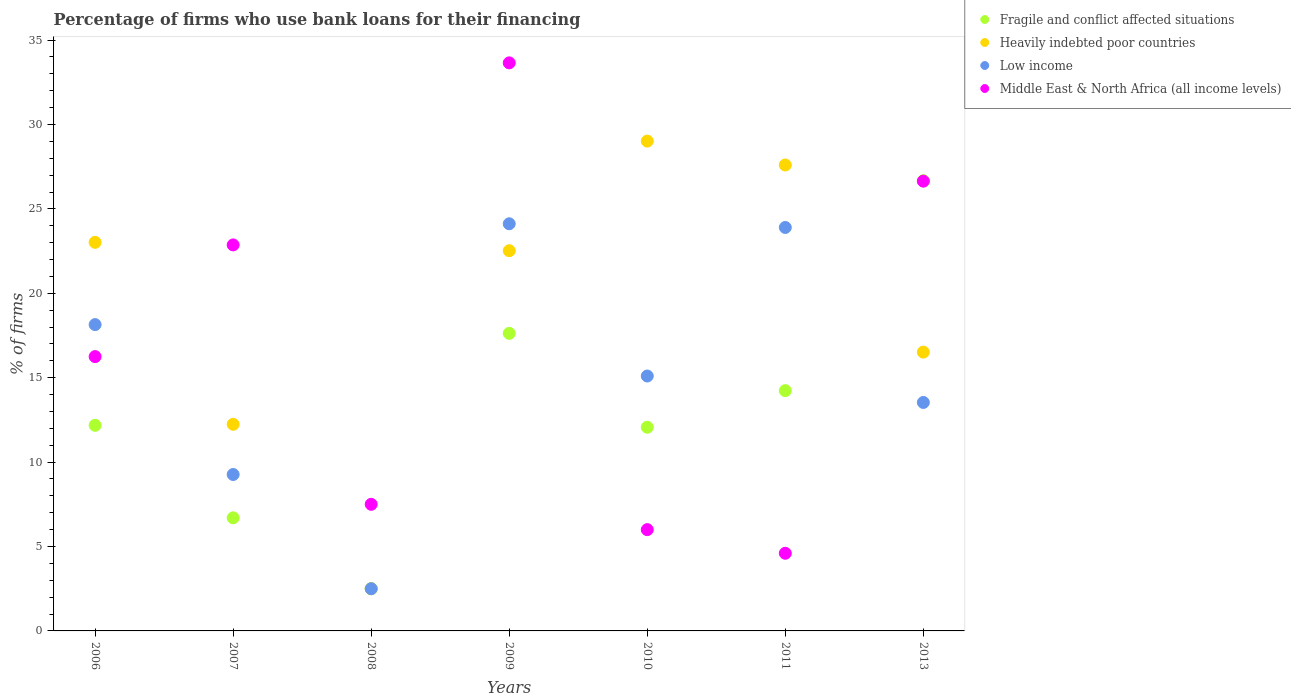How many different coloured dotlines are there?
Keep it short and to the point. 4. What is the percentage of firms who use bank loans for their financing in Low income in 2009?
Give a very brief answer. 24.12. Across all years, what is the maximum percentage of firms who use bank loans for their financing in Low income?
Offer a very short reply. 24.12. Across all years, what is the minimum percentage of firms who use bank loans for their financing in Middle East & North Africa (all income levels)?
Make the answer very short. 4.6. In which year was the percentage of firms who use bank loans for their financing in Middle East & North Africa (all income levels) minimum?
Offer a very short reply. 2011. What is the total percentage of firms who use bank loans for their financing in Fragile and conflict affected situations in the graph?
Offer a very short reply. 91.98. What is the difference between the percentage of firms who use bank loans for their financing in Low income in 2006 and that in 2013?
Your answer should be compact. 4.61. What is the difference between the percentage of firms who use bank loans for their financing in Middle East & North Africa (all income levels) in 2009 and the percentage of firms who use bank loans for their financing in Heavily indebted poor countries in 2007?
Provide a succinct answer. 21.41. What is the average percentage of firms who use bank loans for their financing in Fragile and conflict affected situations per year?
Provide a succinct answer. 13.14. What is the ratio of the percentage of firms who use bank loans for their financing in Fragile and conflict affected situations in 2011 to that in 2013?
Ensure brevity in your answer.  0.53. What is the difference between the highest and the second highest percentage of firms who use bank loans for their financing in Low income?
Offer a terse response. 0.22. What is the difference between the highest and the lowest percentage of firms who use bank loans for their financing in Fragile and conflict affected situations?
Your answer should be compact. 24.17. In how many years, is the percentage of firms who use bank loans for their financing in Heavily indebted poor countries greater than the average percentage of firms who use bank loans for their financing in Heavily indebted poor countries taken over all years?
Keep it short and to the point. 4. Is the sum of the percentage of firms who use bank loans for their financing in Low income in 2006 and 2010 greater than the maximum percentage of firms who use bank loans for their financing in Heavily indebted poor countries across all years?
Your answer should be compact. Yes. Is it the case that in every year, the sum of the percentage of firms who use bank loans for their financing in Middle East & North Africa (all income levels) and percentage of firms who use bank loans for their financing in Fragile and conflict affected situations  is greater than the percentage of firms who use bank loans for their financing in Heavily indebted poor countries?
Your answer should be compact. No. Does the percentage of firms who use bank loans for their financing in Heavily indebted poor countries monotonically increase over the years?
Provide a short and direct response. No. Is the percentage of firms who use bank loans for their financing in Heavily indebted poor countries strictly less than the percentage of firms who use bank loans for their financing in Middle East & North Africa (all income levels) over the years?
Offer a very short reply. No. How many dotlines are there?
Your answer should be very brief. 4. Are the values on the major ticks of Y-axis written in scientific E-notation?
Your response must be concise. No. Does the graph contain any zero values?
Ensure brevity in your answer.  No. Does the graph contain grids?
Provide a short and direct response. No. Where does the legend appear in the graph?
Your answer should be very brief. Top right. How are the legend labels stacked?
Keep it short and to the point. Vertical. What is the title of the graph?
Offer a very short reply. Percentage of firms who use bank loans for their financing. What is the label or title of the Y-axis?
Your response must be concise. % of firms. What is the % of firms in Fragile and conflict affected situations in 2006?
Make the answer very short. 12.18. What is the % of firms of Heavily indebted poor countries in 2006?
Offer a terse response. 23.02. What is the % of firms of Low income in 2006?
Offer a terse response. 18.15. What is the % of firms in Middle East & North Africa (all income levels) in 2006?
Give a very brief answer. 16.25. What is the % of firms of Fragile and conflict affected situations in 2007?
Keep it short and to the point. 6.7. What is the % of firms of Heavily indebted poor countries in 2007?
Ensure brevity in your answer.  12.24. What is the % of firms of Low income in 2007?
Keep it short and to the point. 9.27. What is the % of firms of Middle East & North Africa (all income levels) in 2007?
Your answer should be compact. 22.87. What is the % of firms in Low income in 2008?
Provide a short and direct response. 2.5. What is the % of firms of Middle East & North Africa (all income levels) in 2008?
Make the answer very short. 7.5. What is the % of firms of Fragile and conflict affected situations in 2009?
Provide a short and direct response. 17.63. What is the % of firms in Heavily indebted poor countries in 2009?
Provide a short and direct response. 22.52. What is the % of firms of Low income in 2009?
Your answer should be very brief. 24.12. What is the % of firms of Middle East & North Africa (all income levels) in 2009?
Keep it short and to the point. 33.65. What is the % of firms of Fragile and conflict affected situations in 2010?
Provide a short and direct response. 12.07. What is the % of firms of Heavily indebted poor countries in 2010?
Offer a very short reply. 29.02. What is the % of firms in Fragile and conflict affected situations in 2011?
Make the answer very short. 14.23. What is the % of firms of Heavily indebted poor countries in 2011?
Offer a very short reply. 27.6. What is the % of firms in Low income in 2011?
Provide a short and direct response. 23.9. What is the % of firms in Fragile and conflict affected situations in 2013?
Provide a succinct answer. 26.67. What is the % of firms in Heavily indebted poor countries in 2013?
Your answer should be very brief. 16.52. What is the % of firms of Low income in 2013?
Your answer should be compact. 13.53. What is the % of firms of Middle East & North Africa (all income levels) in 2013?
Make the answer very short. 26.64. Across all years, what is the maximum % of firms of Fragile and conflict affected situations?
Provide a short and direct response. 26.67. Across all years, what is the maximum % of firms in Heavily indebted poor countries?
Provide a short and direct response. 29.02. Across all years, what is the maximum % of firms of Low income?
Give a very brief answer. 24.12. Across all years, what is the maximum % of firms in Middle East & North Africa (all income levels)?
Make the answer very short. 33.65. Across all years, what is the minimum % of firms of Heavily indebted poor countries?
Provide a succinct answer. 2.5. What is the total % of firms of Fragile and conflict affected situations in the graph?
Offer a very short reply. 91.98. What is the total % of firms of Heavily indebted poor countries in the graph?
Offer a terse response. 133.42. What is the total % of firms in Low income in the graph?
Offer a terse response. 106.56. What is the total % of firms in Middle East & North Africa (all income levels) in the graph?
Make the answer very short. 117.51. What is the difference between the % of firms of Fragile and conflict affected situations in 2006 and that in 2007?
Offer a terse response. 5.48. What is the difference between the % of firms in Heavily indebted poor countries in 2006 and that in 2007?
Make the answer very short. 10.78. What is the difference between the % of firms in Low income in 2006 and that in 2007?
Your answer should be compact. 8.88. What is the difference between the % of firms in Middle East & North Africa (all income levels) in 2006 and that in 2007?
Ensure brevity in your answer.  -6.62. What is the difference between the % of firms in Fragile and conflict affected situations in 2006 and that in 2008?
Keep it short and to the point. 9.68. What is the difference between the % of firms in Heavily indebted poor countries in 2006 and that in 2008?
Offer a very short reply. 20.52. What is the difference between the % of firms in Low income in 2006 and that in 2008?
Your response must be concise. 15.65. What is the difference between the % of firms of Middle East & North Africa (all income levels) in 2006 and that in 2008?
Offer a very short reply. 8.75. What is the difference between the % of firms of Fragile and conflict affected situations in 2006 and that in 2009?
Ensure brevity in your answer.  -5.45. What is the difference between the % of firms in Heavily indebted poor countries in 2006 and that in 2009?
Keep it short and to the point. 0.5. What is the difference between the % of firms in Low income in 2006 and that in 2009?
Provide a succinct answer. -5.97. What is the difference between the % of firms in Middle East & North Africa (all income levels) in 2006 and that in 2009?
Offer a very short reply. -17.4. What is the difference between the % of firms of Fragile and conflict affected situations in 2006 and that in 2010?
Offer a very short reply. 0.11. What is the difference between the % of firms in Heavily indebted poor countries in 2006 and that in 2010?
Make the answer very short. -6. What is the difference between the % of firms of Low income in 2006 and that in 2010?
Your response must be concise. 3.05. What is the difference between the % of firms of Middle East & North Africa (all income levels) in 2006 and that in 2010?
Offer a very short reply. 10.25. What is the difference between the % of firms in Fragile and conflict affected situations in 2006 and that in 2011?
Ensure brevity in your answer.  -2.05. What is the difference between the % of firms in Heavily indebted poor countries in 2006 and that in 2011?
Provide a succinct answer. -4.58. What is the difference between the % of firms of Low income in 2006 and that in 2011?
Offer a very short reply. -5.75. What is the difference between the % of firms of Middle East & North Africa (all income levels) in 2006 and that in 2011?
Make the answer very short. 11.65. What is the difference between the % of firms in Fragile and conflict affected situations in 2006 and that in 2013?
Provide a succinct answer. -14.49. What is the difference between the % of firms of Heavily indebted poor countries in 2006 and that in 2013?
Your answer should be compact. 6.5. What is the difference between the % of firms in Low income in 2006 and that in 2013?
Your answer should be very brief. 4.61. What is the difference between the % of firms in Middle East & North Africa (all income levels) in 2006 and that in 2013?
Offer a terse response. -10.39. What is the difference between the % of firms in Fragile and conflict affected situations in 2007 and that in 2008?
Provide a succinct answer. 4.2. What is the difference between the % of firms in Heavily indebted poor countries in 2007 and that in 2008?
Offer a terse response. 9.74. What is the difference between the % of firms of Low income in 2007 and that in 2008?
Your answer should be very brief. 6.77. What is the difference between the % of firms of Middle East & North Africa (all income levels) in 2007 and that in 2008?
Provide a succinct answer. 15.37. What is the difference between the % of firms of Fragile and conflict affected situations in 2007 and that in 2009?
Offer a very short reply. -10.93. What is the difference between the % of firms in Heavily indebted poor countries in 2007 and that in 2009?
Your response must be concise. -10.28. What is the difference between the % of firms of Low income in 2007 and that in 2009?
Make the answer very short. -14.85. What is the difference between the % of firms of Middle East & North Africa (all income levels) in 2007 and that in 2009?
Offer a terse response. -10.78. What is the difference between the % of firms of Fragile and conflict affected situations in 2007 and that in 2010?
Your response must be concise. -5.37. What is the difference between the % of firms of Heavily indebted poor countries in 2007 and that in 2010?
Provide a succinct answer. -16.78. What is the difference between the % of firms of Low income in 2007 and that in 2010?
Offer a terse response. -5.83. What is the difference between the % of firms of Middle East & North Africa (all income levels) in 2007 and that in 2010?
Make the answer very short. 16.87. What is the difference between the % of firms of Fragile and conflict affected situations in 2007 and that in 2011?
Provide a short and direct response. -7.53. What is the difference between the % of firms of Heavily indebted poor countries in 2007 and that in 2011?
Keep it short and to the point. -15.36. What is the difference between the % of firms of Low income in 2007 and that in 2011?
Offer a terse response. -14.63. What is the difference between the % of firms in Middle East & North Africa (all income levels) in 2007 and that in 2011?
Your answer should be compact. 18.27. What is the difference between the % of firms of Fragile and conflict affected situations in 2007 and that in 2013?
Your answer should be compact. -19.97. What is the difference between the % of firms in Heavily indebted poor countries in 2007 and that in 2013?
Offer a very short reply. -4.28. What is the difference between the % of firms in Low income in 2007 and that in 2013?
Your answer should be compact. -4.27. What is the difference between the % of firms in Middle East & North Africa (all income levels) in 2007 and that in 2013?
Your answer should be very brief. -3.78. What is the difference between the % of firms of Fragile and conflict affected situations in 2008 and that in 2009?
Your answer should be compact. -15.13. What is the difference between the % of firms of Heavily indebted poor countries in 2008 and that in 2009?
Ensure brevity in your answer.  -20.02. What is the difference between the % of firms of Low income in 2008 and that in 2009?
Give a very brief answer. -21.62. What is the difference between the % of firms of Middle East & North Africa (all income levels) in 2008 and that in 2009?
Offer a terse response. -26.15. What is the difference between the % of firms of Fragile and conflict affected situations in 2008 and that in 2010?
Keep it short and to the point. -9.57. What is the difference between the % of firms of Heavily indebted poor countries in 2008 and that in 2010?
Your answer should be very brief. -26.52. What is the difference between the % of firms in Low income in 2008 and that in 2010?
Provide a short and direct response. -12.6. What is the difference between the % of firms of Middle East & North Africa (all income levels) in 2008 and that in 2010?
Provide a short and direct response. 1.5. What is the difference between the % of firms of Fragile and conflict affected situations in 2008 and that in 2011?
Keep it short and to the point. -11.73. What is the difference between the % of firms in Heavily indebted poor countries in 2008 and that in 2011?
Your response must be concise. -25.1. What is the difference between the % of firms of Low income in 2008 and that in 2011?
Provide a short and direct response. -21.4. What is the difference between the % of firms in Fragile and conflict affected situations in 2008 and that in 2013?
Make the answer very short. -24.17. What is the difference between the % of firms in Heavily indebted poor countries in 2008 and that in 2013?
Your answer should be compact. -14.02. What is the difference between the % of firms in Low income in 2008 and that in 2013?
Your answer should be very brief. -11.03. What is the difference between the % of firms of Middle East & North Africa (all income levels) in 2008 and that in 2013?
Give a very brief answer. -19.14. What is the difference between the % of firms of Fragile and conflict affected situations in 2009 and that in 2010?
Offer a terse response. 5.56. What is the difference between the % of firms in Heavily indebted poor countries in 2009 and that in 2010?
Give a very brief answer. -6.49. What is the difference between the % of firms in Low income in 2009 and that in 2010?
Make the answer very short. 9.02. What is the difference between the % of firms in Middle East & North Africa (all income levels) in 2009 and that in 2010?
Your response must be concise. 27.65. What is the difference between the % of firms of Fragile and conflict affected situations in 2009 and that in 2011?
Keep it short and to the point. 3.39. What is the difference between the % of firms of Heavily indebted poor countries in 2009 and that in 2011?
Ensure brevity in your answer.  -5.08. What is the difference between the % of firms of Low income in 2009 and that in 2011?
Keep it short and to the point. 0.22. What is the difference between the % of firms of Middle East & North Africa (all income levels) in 2009 and that in 2011?
Your answer should be compact. 29.05. What is the difference between the % of firms of Fragile and conflict affected situations in 2009 and that in 2013?
Your response must be concise. -9.04. What is the difference between the % of firms in Heavily indebted poor countries in 2009 and that in 2013?
Provide a short and direct response. 6.01. What is the difference between the % of firms of Low income in 2009 and that in 2013?
Provide a short and direct response. 10.58. What is the difference between the % of firms of Middle East & North Africa (all income levels) in 2009 and that in 2013?
Your response must be concise. 7.01. What is the difference between the % of firms in Fragile and conflict affected situations in 2010 and that in 2011?
Give a very brief answer. -2.17. What is the difference between the % of firms of Heavily indebted poor countries in 2010 and that in 2011?
Keep it short and to the point. 1.42. What is the difference between the % of firms of Fragile and conflict affected situations in 2010 and that in 2013?
Ensure brevity in your answer.  -14.6. What is the difference between the % of firms of Low income in 2010 and that in 2013?
Offer a very short reply. 1.57. What is the difference between the % of firms in Middle East & North Africa (all income levels) in 2010 and that in 2013?
Your response must be concise. -20.64. What is the difference between the % of firms of Fragile and conflict affected situations in 2011 and that in 2013?
Offer a terse response. -12.44. What is the difference between the % of firms of Heavily indebted poor countries in 2011 and that in 2013?
Offer a terse response. 11.08. What is the difference between the % of firms in Low income in 2011 and that in 2013?
Offer a very short reply. 10.37. What is the difference between the % of firms in Middle East & North Africa (all income levels) in 2011 and that in 2013?
Provide a short and direct response. -22.04. What is the difference between the % of firms in Fragile and conflict affected situations in 2006 and the % of firms in Heavily indebted poor countries in 2007?
Offer a terse response. -0.06. What is the difference between the % of firms in Fragile and conflict affected situations in 2006 and the % of firms in Low income in 2007?
Your answer should be very brief. 2.91. What is the difference between the % of firms of Fragile and conflict affected situations in 2006 and the % of firms of Middle East & North Africa (all income levels) in 2007?
Provide a succinct answer. -10.69. What is the difference between the % of firms of Heavily indebted poor countries in 2006 and the % of firms of Low income in 2007?
Provide a short and direct response. 13.75. What is the difference between the % of firms of Heavily indebted poor countries in 2006 and the % of firms of Middle East & North Africa (all income levels) in 2007?
Keep it short and to the point. 0.15. What is the difference between the % of firms in Low income in 2006 and the % of firms in Middle East & North Africa (all income levels) in 2007?
Provide a short and direct response. -4.72. What is the difference between the % of firms of Fragile and conflict affected situations in 2006 and the % of firms of Heavily indebted poor countries in 2008?
Keep it short and to the point. 9.68. What is the difference between the % of firms in Fragile and conflict affected situations in 2006 and the % of firms in Low income in 2008?
Ensure brevity in your answer.  9.68. What is the difference between the % of firms in Fragile and conflict affected situations in 2006 and the % of firms in Middle East & North Africa (all income levels) in 2008?
Give a very brief answer. 4.68. What is the difference between the % of firms of Heavily indebted poor countries in 2006 and the % of firms of Low income in 2008?
Offer a very short reply. 20.52. What is the difference between the % of firms of Heavily indebted poor countries in 2006 and the % of firms of Middle East & North Africa (all income levels) in 2008?
Provide a short and direct response. 15.52. What is the difference between the % of firms in Low income in 2006 and the % of firms in Middle East & North Africa (all income levels) in 2008?
Provide a short and direct response. 10.65. What is the difference between the % of firms in Fragile and conflict affected situations in 2006 and the % of firms in Heavily indebted poor countries in 2009?
Your answer should be compact. -10.34. What is the difference between the % of firms of Fragile and conflict affected situations in 2006 and the % of firms of Low income in 2009?
Make the answer very short. -11.94. What is the difference between the % of firms of Fragile and conflict affected situations in 2006 and the % of firms of Middle East & North Africa (all income levels) in 2009?
Keep it short and to the point. -21.47. What is the difference between the % of firms of Heavily indebted poor countries in 2006 and the % of firms of Low income in 2009?
Your answer should be compact. -1.1. What is the difference between the % of firms of Heavily indebted poor countries in 2006 and the % of firms of Middle East & North Africa (all income levels) in 2009?
Give a very brief answer. -10.63. What is the difference between the % of firms of Low income in 2006 and the % of firms of Middle East & North Africa (all income levels) in 2009?
Give a very brief answer. -15.5. What is the difference between the % of firms of Fragile and conflict affected situations in 2006 and the % of firms of Heavily indebted poor countries in 2010?
Your response must be concise. -16.84. What is the difference between the % of firms in Fragile and conflict affected situations in 2006 and the % of firms in Low income in 2010?
Provide a short and direct response. -2.92. What is the difference between the % of firms of Fragile and conflict affected situations in 2006 and the % of firms of Middle East & North Africa (all income levels) in 2010?
Ensure brevity in your answer.  6.18. What is the difference between the % of firms in Heavily indebted poor countries in 2006 and the % of firms in Low income in 2010?
Give a very brief answer. 7.92. What is the difference between the % of firms of Heavily indebted poor countries in 2006 and the % of firms of Middle East & North Africa (all income levels) in 2010?
Make the answer very short. 17.02. What is the difference between the % of firms of Low income in 2006 and the % of firms of Middle East & North Africa (all income levels) in 2010?
Ensure brevity in your answer.  12.15. What is the difference between the % of firms of Fragile and conflict affected situations in 2006 and the % of firms of Heavily indebted poor countries in 2011?
Keep it short and to the point. -15.42. What is the difference between the % of firms in Fragile and conflict affected situations in 2006 and the % of firms in Low income in 2011?
Make the answer very short. -11.72. What is the difference between the % of firms in Fragile and conflict affected situations in 2006 and the % of firms in Middle East & North Africa (all income levels) in 2011?
Provide a succinct answer. 7.58. What is the difference between the % of firms of Heavily indebted poor countries in 2006 and the % of firms of Low income in 2011?
Your answer should be compact. -0.88. What is the difference between the % of firms of Heavily indebted poor countries in 2006 and the % of firms of Middle East & North Africa (all income levels) in 2011?
Provide a short and direct response. 18.42. What is the difference between the % of firms in Low income in 2006 and the % of firms in Middle East & North Africa (all income levels) in 2011?
Ensure brevity in your answer.  13.55. What is the difference between the % of firms of Fragile and conflict affected situations in 2006 and the % of firms of Heavily indebted poor countries in 2013?
Give a very brief answer. -4.34. What is the difference between the % of firms in Fragile and conflict affected situations in 2006 and the % of firms in Low income in 2013?
Keep it short and to the point. -1.35. What is the difference between the % of firms in Fragile and conflict affected situations in 2006 and the % of firms in Middle East & North Africa (all income levels) in 2013?
Make the answer very short. -14.46. What is the difference between the % of firms in Heavily indebted poor countries in 2006 and the % of firms in Low income in 2013?
Your answer should be compact. 9.49. What is the difference between the % of firms in Heavily indebted poor countries in 2006 and the % of firms in Middle East & North Africa (all income levels) in 2013?
Provide a short and direct response. -3.62. What is the difference between the % of firms in Low income in 2006 and the % of firms in Middle East & North Africa (all income levels) in 2013?
Ensure brevity in your answer.  -8.5. What is the difference between the % of firms of Fragile and conflict affected situations in 2007 and the % of firms of Heavily indebted poor countries in 2008?
Offer a terse response. 4.2. What is the difference between the % of firms of Fragile and conflict affected situations in 2007 and the % of firms of Middle East & North Africa (all income levels) in 2008?
Offer a very short reply. -0.8. What is the difference between the % of firms in Heavily indebted poor countries in 2007 and the % of firms in Low income in 2008?
Keep it short and to the point. 9.74. What is the difference between the % of firms in Heavily indebted poor countries in 2007 and the % of firms in Middle East & North Africa (all income levels) in 2008?
Ensure brevity in your answer.  4.74. What is the difference between the % of firms of Low income in 2007 and the % of firms of Middle East & North Africa (all income levels) in 2008?
Ensure brevity in your answer.  1.77. What is the difference between the % of firms in Fragile and conflict affected situations in 2007 and the % of firms in Heavily indebted poor countries in 2009?
Keep it short and to the point. -15.82. What is the difference between the % of firms in Fragile and conflict affected situations in 2007 and the % of firms in Low income in 2009?
Your answer should be very brief. -17.42. What is the difference between the % of firms in Fragile and conflict affected situations in 2007 and the % of firms in Middle East & North Africa (all income levels) in 2009?
Your answer should be very brief. -26.95. What is the difference between the % of firms in Heavily indebted poor countries in 2007 and the % of firms in Low income in 2009?
Your response must be concise. -11.88. What is the difference between the % of firms of Heavily indebted poor countries in 2007 and the % of firms of Middle East & North Africa (all income levels) in 2009?
Provide a short and direct response. -21.41. What is the difference between the % of firms in Low income in 2007 and the % of firms in Middle East & North Africa (all income levels) in 2009?
Make the answer very short. -24.38. What is the difference between the % of firms in Fragile and conflict affected situations in 2007 and the % of firms in Heavily indebted poor countries in 2010?
Ensure brevity in your answer.  -22.32. What is the difference between the % of firms in Fragile and conflict affected situations in 2007 and the % of firms in Low income in 2010?
Provide a short and direct response. -8.4. What is the difference between the % of firms of Fragile and conflict affected situations in 2007 and the % of firms of Middle East & North Africa (all income levels) in 2010?
Your answer should be compact. 0.7. What is the difference between the % of firms in Heavily indebted poor countries in 2007 and the % of firms in Low income in 2010?
Keep it short and to the point. -2.86. What is the difference between the % of firms in Heavily indebted poor countries in 2007 and the % of firms in Middle East & North Africa (all income levels) in 2010?
Offer a terse response. 6.24. What is the difference between the % of firms of Low income in 2007 and the % of firms of Middle East & North Africa (all income levels) in 2010?
Provide a short and direct response. 3.27. What is the difference between the % of firms of Fragile and conflict affected situations in 2007 and the % of firms of Heavily indebted poor countries in 2011?
Provide a succinct answer. -20.9. What is the difference between the % of firms in Fragile and conflict affected situations in 2007 and the % of firms in Low income in 2011?
Make the answer very short. -17.2. What is the difference between the % of firms of Heavily indebted poor countries in 2007 and the % of firms of Low income in 2011?
Offer a very short reply. -11.66. What is the difference between the % of firms in Heavily indebted poor countries in 2007 and the % of firms in Middle East & North Africa (all income levels) in 2011?
Provide a short and direct response. 7.64. What is the difference between the % of firms of Low income in 2007 and the % of firms of Middle East & North Africa (all income levels) in 2011?
Provide a short and direct response. 4.67. What is the difference between the % of firms in Fragile and conflict affected situations in 2007 and the % of firms in Heavily indebted poor countries in 2013?
Provide a short and direct response. -9.82. What is the difference between the % of firms of Fragile and conflict affected situations in 2007 and the % of firms of Low income in 2013?
Give a very brief answer. -6.83. What is the difference between the % of firms of Fragile and conflict affected situations in 2007 and the % of firms of Middle East & North Africa (all income levels) in 2013?
Keep it short and to the point. -19.94. What is the difference between the % of firms in Heavily indebted poor countries in 2007 and the % of firms in Low income in 2013?
Your answer should be very brief. -1.29. What is the difference between the % of firms in Heavily indebted poor countries in 2007 and the % of firms in Middle East & North Africa (all income levels) in 2013?
Give a very brief answer. -14.4. What is the difference between the % of firms of Low income in 2007 and the % of firms of Middle East & North Africa (all income levels) in 2013?
Provide a short and direct response. -17.38. What is the difference between the % of firms of Fragile and conflict affected situations in 2008 and the % of firms of Heavily indebted poor countries in 2009?
Keep it short and to the point. -20.02. What is the difference between the % of firms of Fragile and conflict affected situations in 2008 and the % of firms of Low income in 2009?
Make the answer very short. -21.62. What is the difference between the % of firms in Fragile and conflict affected situations in 2008 and the % of firms in Middle East & North Africa (all income levels) in 2009?
Offer a very short reply. -31.15. What is the difference between the % of firms in Heavily indebted poor countries in 2008 and the % of firms in Low income in 2009?
Ensure brevity in your answer.  -21.62. What is the difference between the % of firms in Heavily indebted poor countries in 2008 and the % of firms in Middle East & North Africa (all income levels) in 2009?
Your answer should be very brief. -31.15. What is the difference between the % of firms in Low income in 2008 and the % of firms in Middle East & North Africa (all income levels) in 2009?
Keep it short and to the point. -31.15. What is the difference between the % of firms in Fragile and conflict affected situations in 2008 and the % of firms in Heavily indebted poor countries in 2010?
Your answer should be very brief. -26.52. What is the difference between the % of firms in Fragile and conflict affected situations in 2008 and the % of firms in Middle East & North Africa (all income levels) in 2010?
Keep it short and to the point. -3.5. What is the difference between the % of firms in Low income in 2008 and the % of firms in Middle East & North Africa (all income levels) in 2010?
Your answer should be very brief. -3.5. What is the difference between the % of firms in Fragile and conflict affected situations in 2008 and the % of firms in Heavily indebted poor countries in 2011?
Ensure brevity in your answer.  -25.1. What is the difference between the % of firms of Fragile and conflict affected situations in 2008 and the % of firms of Low income in 2011?
Your answer should be compact. -21.4. What is the difference between the % of firms of Fragile and conflict affected situations in 2008 and the % of firms of Middle East & North Africa (all income levels) in 2011?
Your response must be concise. -2.1. What is the difference between the % of firms of Heavily indebted poor countries in 2008 and the % of firms of Low income in 2011?
Provide a succinct answer. -21.4. What is the difference between the % of firms in Low income in 2008 and the % of firms in Middle East & North Africa (all income levels) in 2011?
Keep it short and to the point. -2.1. What is the difference between the % of firms in Fragile and conflict affected situations in 2008 and the % of firms in Heavily indebted poor countries in 2013?
Give a very brief answer. -14.02. What is the difference between the % of firms in Fragile and conflict affected situations in 2008 and the % of firms in Low income in 2013?
Offer a terse response. -11.03. What is the difference between the % of firms in Fragile and conflict affected situations in 2008 and the % of firms in Middle East & North Africa (all income levels) in 2013?
Your answer should be compact. -24.14. What is the difference between the % of firms in Heavily indebted poor countries in 2008 and the % of firms in Low income in 2013?
Your response must be concise. -11.03. What is the difference between the % of firms in Heavily indebted poor countries in 2008 and the % of firms in Middle East & North Africa (all income levels) in 2013?
Your response must be concise. -24.14. What is the difference between the % of firms of Low income in 2008 and the % of firms of Middle East & North Africa (all income levels) in 2013?
Offer a terse response. -24.14. What is the difference between the % of firms of Fragile and conflict affected situations in 2009 and the % of firms of Heavily indebted poor countries in 2010?
Provide a succinct answer. -11.39. What is the difference between the % of firms of Fragile and conflict affected situations in 2009 and the % of firms of Low income in 2010?
Provide a succinct answer. 2.53. What is the difference between the % of firms of Fragile and conflict affected situations in 2009 and the % of firms of Middle East & North Africa (all income levels) in 2010?
Make the answer very short. 11.63. What is the difference between the % of firms of Heavily indebted poor countries in 2009 and the % of firms of Low income in 2010?
Your answer should be compact. 7.42. What is the difference between the % of firms of Heavily indebted poor countries in 2009 and the % of firms of Middle East & North Africa (all income levels) in 2010?
Give a very brief answer. 16.52. What is the difference between the % of firms in Low income in 2009 and the % of firms in Middle East & North Africa (all income levels) in 2010?
Keep it short and to the point. 18.12. What is the difference between the % of firms in Fragile and conflict affected situations in 2009 and the % of firms in Heavily indebted poor countries in 2011?
Provide a short and direct response. -9.97. What is the difference between the % of firms of Fragile and conflict affected situations in 2009 and the % of firms of Low income in 2011?
Offer a very short reply. -6.27. What is the difference between the % of firms in Fragile and conflict affected situations in 2009 and the % of firms in Middle East & North Africa (all income levels) in 2011?
Provide a succinct answer. 13.03. What is the difference between the % of firms of Heavily indebted poor countries in 2009 and the % of firms of Low income in 2011?
Give a very brief answer. -1.38. What is the difference between the % of firms in Heavily indebted poor countries in 2009 and the % of firms in Middle East & North Africa (all income levels) in 2011?
Provide a succinct answer. 17.92. What is the difference between the % of firms of Low income in 2009 and the % of firms of Middle East & North Africa (all income levels) in 2011?
Keep it short and to the point. 19.52. What is the difference between the % of firms in Fragile and conflict affected situations in 2009 and the % of firms in Heavily indebted poor countries in 2013?
Offer a very short reply. 1.11. What is the difference between the % of firms in Fragile and conflict affected situations in 2009 and the % of firms in Low income in 2013?
Provide a succinct answer. 4.09. What is the difference between the % of firms of Fragile and conflict affected situations in 2009 and the % of firms of Middle East & North Africa (all income levels) in 2013?
Make the answer very short. -9.02. What is the difference between the % of firms in Heavily indebted poor countries in 2009 and the % of firms in Low income in 2013?
Offer a terse response. 8.99. What is the difference between the % of firms in Heavily indebted poor countries in 2009 and the % of firms in Middle East & North Africa (all income levels) in 2013?
Ensure brevity in your answer.  -4.12. What is the difference between the % of firms of Low income in 2009 and the % of firms of Middle East & North Africa (all income levels) in 2013?
Offer a terse response. -2.52. What is the difference between the % of firms in Fragile and conflict affected situations in 2010 and the % of firms in Heavily indebted poor countries in 2011?
Your response must be concise. -15.53. What is the difference between the % of firms of Fragile and conflict affected situations in 2010 and the % of firms of Low income in 2011?
Provide a succinct answer. -11.83. What is the difference between the % of firms of Fragile and conflict affected situations in 2010 and the % of firms of Middle East & North Africa (all income levels) in 2011?
Provide a succinct answer. 7.47. What is the difference between the % of firms in Heavily indebted poor countries in 2010 and the % of firms in Low income in 2011?
Ensure brevity in your answer.  5.12. What is the difference between the % of firms of Heavily indebted poor countries in 2010 and the % of firms of Middle East & North Africa (all income levels) in 2011?
Your answer should be very brief. 24.42. What is the difference between the % of firms in Fragile and conflict affected situations in 2010 and the % of firms in Heavily indebted poor countries in 2013?
Your answer should be very brief. -4.45. What is the difference between the % of firms in Fragile and conflict affected situations in 2010 and the % of firms in Low income in 2013?
Offer a very short reply. -1.47. What is the difference between the % of firms in Fragile and conflict affected situations in 2010 and the % of firms in Middle East & North Africa (all income levels) in 2013?
Offer a very short reply. -14.58. What is the difference between the % of firms of Heavily indebted poor countries in 2010 and the % of firms of Low income in 2013?
Ensure brevity in your answer.  15.48. What is the difference between the % of firms of Heavily indebted poor countries in 2010 and the % of firms of Middle East & North Africa (all income levels) in 2013?
Your response must be concise. 2.37. What is the difference between the % of firms in Low income in 2010 and the % of firms in Middle East & North Africa (all income levels) in 2013?
Your answer should be very brief. -11.54. What is the difference between the % of firms in Fragile and conflict affected situations in 2011 and the % of firms in Heavily indebted poor countries in 2013?
Provide a succinct answer. -2.28. What is the difference between the % of firms in Fragile and conflict affected situations in 2011 and the % of firms in Low income in 2013?
Your answer should be compact. 0.7. What is the difference between the % of firms in Fragile and conflict affected situations in 2011 and the % of firms in Middle East & North Africa (all income levels) in 2013?
Keep it short and to the point. -12.41. What is the difference between the % of firms of Heavily indebted poor countries in 2011 and the % of firms of Low income in 2013?
Provide a succinct answer. 14.07. What is the difference between the % of firms of Heavily indebted poor countries in 2011 and the % of firms of Middle East & North Africa (all income levels) in 2013?
Your response must be concise. 0.96. What is the difference between the % of firms of Low income in 2011 and the % of firms of Middle East & North Africa (all income levels) in 2013?
Offer a terse response. -2.74. What is the average % of firms of Fragile and conflict affected situations per year?
Keep it short and to the point. 13.14. What is the average % of firms of Heavily indebted poor countries per year?
Ensure brevity in your answer.  19.06. What is the average % of firms of Low income per year?
Keep it short and to the point. 15.22. What is the average % of firms of Middle East & North Africa (all income levels) per year?
Offer a terse response. 16.79. In the year 2006, what is the difference between the % of firms of Fragile and conflict affected situations and % of firms of Heavily indebted poor countries?
Keep it short and to the point. -10.84. In the year 2006, what is the difference between the % of firms of Fragile and conflict affected situations and % of firms of Low income?
Provide a succinct answer. -5.97. In the year 2006, what is the difference between the % of firms in Fragile and conflict affected situations and % of firms in Middle East & North Africa (all income levels)?
Offer a terse response. -4.07. In the year 2006, what is the difference between the % of firms in Heavily indebted poor countries and % of firms in Low income?
Make the answer very short. 4.87. In the year 2006, what is the difference between the % of firms in Heavily indebted poor countries and % of firms in Middle East & North Africa (all income levels)?
Give a very brief answer. 6.77. In the year 2006, what is the difference between the % of firms of Low income and % of firms of Middle East & North Africa (all income levels)?
Give a very brief answer. 1.9. In the year 2007, what is the difference between the % of firms of Fragile and conflict affected situations and % of firms of Heavily indebted poor countries?
Your answer should be very brief. -5.54. In the year 2007, what is the difference between the % of firms of Fragile and conflict affected situations and % of firms of Low income?
Provide a succinct answer. -2.57. In the year 2007, what is the difference between the % of firms of Fragile and conflict affected situations and % of firms of Middle East & North Africa (all income levels)?
Make the answer very short. -16.17. In the year 2007, what is the difference between the % of firms of Heavily indebted poor countries and % of firms of Low income?
Your answer should be compact. 2.97. In the year 2007, what is the difference between the % of firms in Heavily indebted poor countries and % of firms in Middle East & North Africa (all income levels)?
Offer a terse response. -10.63. In the year 2008, what is the difference between the % of firms of Fragile and conflict affected situations and % of firms of Heavily indebted poor countries?
Your answer should be compact. 0. In the year 2008, what is the difference between the % of firms of Heavily indebted poor countries and % of firms of Low income?
Your answer should be compact. 0. In the year 2008, what is the difference between the % of firms in Heavily indebted poor countries and % of firms in Middle East & North Africa (all income levels)?
Keep it short and to the point. -5. In the year 2009, what is the difference between the % of firms of Fragile and conflict affected situations and % of firms of Heavily indebted poor countries?
Ensure brevity in your answer.  -4.9. In the year 2009, what is the difference between the % of firms of Fragile and conflict affected situations and % of firms of Low income?
Keep it short and to the point. -6.49. In the year 2009, what is the difference between the % of firms in Fragile and conflict affected situations and % of firms in Middle East & North Africa (all income levels)?
Provide a short and direct response. -16.02. In the year 2009, what is the difference between the % of firms of Heavily indebted poor countries and % of firms of Low income?
Offer a terse response. -1.6. In the year 2009, what is the difference between the % of firms in Heavily indebted poor countries and % of firms in Middle East & North Africa (all income levels)?
Provide a succinct answer. -11.13. In the year 2009, what is the difference between the % of firms in Low income and % of firms in Middle East & North Africa (all income levels)?
Your answer should be very brief. -9.53. In the year 2010, what is the difference between the % of firms of Fragile and conflict affected situations and % of firms of Heavily indebted poor countries?
Ensure brevity in your answer.  -16.95. In the year 2010, what is the difference between the % of firms of Fragile and conflict affected situations and % of firms of Low income?
Keep it short and to the point. -3.03. In the year 2010, what is the difference between the % of firms in Fragile and conflict affected situations and % of firms in Middle East & North Africa (all income levels)?
Offer a very short reply. 6.07. In the year 2010, what is the difference between the % of firms in Heavily indebted poor countries and % of firms in Low income?
Your answer should be compact. 13.92. In the year 2010, what is the difference between the % of firms of Heavily indebted poor countries and % of firms of Middle East & North Africa (all income levels)?
Provide a succinct answer. 23.02. In the year 2011, what is the difference between the % of firms in Fragile and conflict affected situations and % of firms in Heavily indebted poor countries?
Your answer should be compact. -13.37. In the year 2011, what is the difference between the % of firms of Fragile and conflict affected situations and % of firms of Low income?
Make the answer very short. -9.67. In the year 2011, what is the difference between the % of firms of Fragile and conflict affected situations and % of firms of Middle East & North Africa (all income levels)?
Make the answer very short. 9.63. In the year 2011, what is the difference between the % of firms of Heavily indebted poor countries and % of firms of Low income?
Provide a succinct answer. 3.7. In the year 2011, what is the difference between the % of firms of Low income and % of firms of Middle East & North Africa (all income levels)?
Your answer should be compact. 19.3. In the year 2013, what is the difference between the % of firms of Fragile and conflict affected situations and % of firms of Heavily indebted poor countries?
Offer a terse response. 10.15. In the year 2013, what is the difference between the % of firms of Fragile and conflict affected situations and % of firms of Low income?
Keep it short and to the point. 13.14. In the year 2013, what is the difference between the % of firms of Fragile and conflict affected situations and % of firms of Middle East & North Africa (all income levels)?
Offer a terse response. 0.03. In the year 2013, what is the difference between the % of firms of Heavily indebted poor countries and % of firms of Low income?
Your answer should be compact. 2.98. In the year 2013, what is the difference between the % of firms of Heavily indebted poor countries and % of firms of Middle East & North Africa (all income levels)?
Make the answer very short. -10.13. In the year 2013, what is the difference between the % of firms in Low income and % of firms in Middle East & North Africa (all income levels)?
Provide a succinct answer. -13.11. What is the ratio of the % of firms in Fragile and conflict affected situations in 2006 to that in 2007?
Offer a very short reply. 1.82. What is the ratio of the % of firms of Heavily indebted poor countries in 2006 to that in 2007?
Provide a succinct answer. 1.88. What is the ratio of the % of firms of Low income in 2006 to that in 2007?
Offer a terse response. 1.96. What is the ratio of the % of firms in Middle East & North Africa (all income levels) in 2006 to that in 2007?
Your answer should be very brief. 0.71. What is the ratio of the % of firms of Fragile and conflict affected situations in 2006 to that in 2008?
Offer a very short reply. 4.87. What is the ratio of the % of firms in Heavily indebted poor countries in 2006 to that in 2008?
Offer a very short reply. 9.21. What is the ratio of the % of firms in Low income in 2006 to that in 2008?
Give a very brief answer. 7.26. What is the ratio of the % of firms in Middle East & North Africa (all income levels) in 2006 to that in 2008?
Offer a terse response. 2.17. What is the ratio of the % of firms of Fragile and conflict affected situations in 2006 to that in 2009?
Offer a very short reply. 0.69. What is the ratio of the % of firms in Low income in 2006 to that in 2009?
Provide a succinct answer. 0.75. What is the ratio of the % of firms of Middle East & North Africa (all income levels) in 2006 to that in 2009?
Make the answer very short. 0.48. What is the ratio of the % of firms in Fragile and conflict affected situations in 2006 to that in 2010?
Offer a very short reply. 1.01. What is the ratio of the % of firms in Heavily indebted poor countries in 2006 to that in 2010?
Provide a succinct answer. 0.79. What is the ratio of the % of firms of Low income in 2006 to that in 2010?
Provide a succinct answer. 1.2. What is the ratio of the % of firms in Middle East & North Africa (all income levels) in 2006 to that in 2010?
Give a very brief answer. 2.71. What is the ratio of the % of firms in Fragile and conflict affected situations in 2006 to that in 2011?
Offer a terse response. 0.86. What is the ratio of the % of firms in Heavily indebted poor countries in 2006 to that in 2011?
Your response must be concise. 0.83. What is the ratio of the % of firms of Low income in 2006 to that in 2011?
Give a very brief answer. 0.76. What is the ratio of the % of firms of Middle East & North Africa (all income levels) in 2006 to that in 2011?
Offer a very short reply. 3.53. What is the ratio of the % of firms in Fragile and conflict affected situations in 2006 to that in 2013?
Ensure brevity in your answer.  0.46. What is the ratio of the % of firms in Heavily indebted poor countries in 2006 to that in 2013?
Your response must be concise. 1.39. What is the ratio of the % of firms in Low income in 2006 to that in 2013?
Your response must be concise. 1.34. What is the ratio of the % of firms in Middle East & North Africa (all income levels) in 2006 to that in 2013?
Your answer should be compact. 0.61. What is the ratio of the % of firms in Fragile and conflict affected situations in 2007 to that in 2008?
Ensure brevity in your answer.  2.68. What is the ratio of the % of firms in Heavily indebted poor countries in 2007 to that in 2008?
Offer a very short reply. 4.9. What is the ratio of the % of firms in Low income in 2007 to that in 2008?
Offer a very short reply. 3.71. What is the ratio of the % of firms in Middle East & North Africa (all income levels) in 2007 to that in 2008?
Ensure brevity in your answer.  3.05. What is the ratio of the % of firms in Fragile and conflict affected situations in 2007 to that in 2009?
Offer a terse response. 0.38. What is the ratio of the % of firms in Heavily indebted poor countries in 2007 to that in 2009?
Your response must be concise. 0.54. What is the ratio of the % of firms of Low income in 2007 to that in 2009?
Provide a succinct answer. 0.38. What is the ratio of the % of firms in Middle East & North Africa (all income levels) in 2007 to that in 2009?
Provide a short and direct response. 0.68. What is the ratio of the % of firms of Fragile and conflict affected situations in 2007 to that in 2010?
Make the answer very short. 0.56. What is the ratio of the % of firms of Heavily indebted poor countries in 2007 to that in 2010?
Give a very brief answer. 0.42. What is the ratio of the % of firms of Low income in 2007 to that in 2010?
Provide a short and direct response. 0.61. What is the ratio of the % of firms of Middle East & North Africa (all income levels) in 2007 to that in 2010?
Ensure brevity in your answer.  3.81. What is the ratio of the % of firms in Fragile and conflict affected situations in 2007 to that in 2011?
Your answer should be very brief. 0.47. What is the ratio of the % of firms in Heavily indebted poor countries in 2007 to that in 2011?
Provide a succinct answer. 0.44. What is the ratio of the % of firms in Low income in 2007 to that in 2011?
Offer a very short reply. 0.39. What is the ratio of the % of firms of Middle East & North Africa (all income levels) in 2007 to that in 2011?
Provide a succinct answer. 4.97. What is the ratio of the % of firms of Fragile and conflict affected situations in 2007 to that in 2013?
Your answer should be very brief. 0.25. What is the ratio of the % of firms in Heavily indebted poor countries in 2007 to that in 2013?
Offer a very short reply. 0.74. What is the ratio of the % of firms of Low income in 2007 to that in 2013?
Ensure brevity in your answer.  0.68. What is the ratio of the % of firms of Middle East & North Africa (all income levels) in 2007 to that in 2013?
Give a very brief answer. 0.86. What is the ratio of the % of firms of Fragile and conflict affected situations in 2008 to that in 2009?
Keep it short and to the point. 0.14. What is the ratio of the % of firms in Heavily indebted poor countries in 2008 to that in 2009?
Give a very brief answer. 0.11. What is the ratio of the % of firms in Low income in 2008 to that in 2009?
Provide a succinct answer. 0.1. What is the ratio of the % of firms of Middle East & North Africa (all income levels) in 2008 to that in 2009?
Your answer should be compact. 0.22. What is the ratio of the % of firms in Fragile and conflict affected situations in 2008 to that in 2010?
Keep it short and to the point. 0.21. What is the ratio of the % of firms of Heavily indebted poor countries in 2008 to that in 2010?
Provide a succinct answer. 0.09. What is the ratio of the % of firms of Low income in 2008 to that in 2010?
Your answer should be very brief. 0.17. What is the ratio of the % of firms of Fragile and conflict affected situations in 2008 to that in 2011?
Your answer should be very brief. 0.18. What is the ratio of the % of firms of Heavily indebted poor countries in 2008 to that in 2011?
Give a very brief answer. 0.09. What is the ratio of the % of firms in Low income in 2008 to that in 2011?
Your answer should be compact. 0.1. What is the ratio of the % of firms of Middle East & North Africa (all income levels) in 2008 to that in 2011?
Offer a terse response. 1.63. What is the ratio of the % of firms in Fragile and conflict affected situations in 2008 to that in 2013?
Offer a very short reply. 0.09. What is the ratio of the % of firms in Heavily indebted poor countries in 2008 to that in 2013?
Make the answer very short. 0.15. What is the ratio of the % of firms in Low income in 2008 to that in 2013?
Give a very brief answer. 0.18. What is the ratio of the % of firms in Middle East & North Africa (all income levels) in 2008 to that in 2013?
Give a very brief answer. 0.28. What is the ratio of the % of firms in Fragile and conflict affected situations in 2009 to that in 2010?
Your response must be concise. 1.46. What is the ratio of the % of firms of Heavily indebted poor countries in 2009 to that in 2010?
Keep it short and to the point. 0.78. What is the ratio of the % of firms in Low income in 2009 to that in 2010?
Your answer should be very brief. 1.6. What is the ratio of the % of firms of Middle East & North Africa (all income levels) in 2009 to that in 2010?
Give a very brief answer. 5.61. What is the ratio of the % of firms in Fragile and conflict affected situations in 2009 to that in 2011?
Give a very brief answer. 1.24. What is the ratio of the % of firms of Heavily indebted poor countries in 2009 to that in 2011?
Ensure brevity in your answer.  0.82. What is the ratio of the % of firms in Low income in 2009 to that in 2011?
Make the answer very short. 1.01. What is the ratio of the % of firms in Middle East & North Africa (all income levels) in 2009 to that in 2011?
Keep it short and to the point. 7.32. What is the ratio of the % of firms in Fragile and conflict affected situations in 2009 to that in 2013?
Ensure brevity in your answer.  0.66. What is the ratio of the % of firms in Heavily indebted poor countries in 2009 to that in 2013?
Offer a terse response. 1.36. What is the ratio of the % of firms of Low income in 2009 to that in 2013?
Give a very brief answer. 1.78. What is the ratio of the % of firms in Middle East & North Africa (all income levels) in 2009 to that in 2013?
Provide a short and direct response. 1.26. What is the ratio of the % of firms of Fragile and conflict affected situations in 2010 to that in 2011?
Your answer should be very brief. 0.85. What is the ratio of the % of firms of Heavily indebted poor countries in 2010 to that in 2011?
Keep it short and to the point. 1.05. What is the ratio of the % of firms of Low income in 2010 to that in 2011?
Provide a succinct answer. 0.63. What is the ratio of the % of firms in Middle East & North Africa (all income levels) in 2010 to that in 2011?
Offer a terse response. 1.3. What is the ratio of the % of firms in Fragile and conflict affected situations in 2010 to that in 2013?
Give a very brief answer. 0.45. What is the ratio of the % of firms of Heavily indebted poor countries in 2010 to that in 2013?
Ensure brevity in your answer.  1.76. What is the ratio of the % of firms of Low income in 2010 to that in 2013?
Your response must be concise. 1.12. What is the ratio of the % of firms in Middle East & North Africa (all income levels) in 2010 to that in 2013?
Provide a succinct answer. 0.23. What is the ratio of the % of firms of Fragile and conflict affected situations in 2011 to that in 2013?
Make the answer very short. 0.53. What is the ratio of the % of firms in Heavily indebted poor countries in 2011 to that in 2013?
Offer a very short reply. 1.67. What is the ratio of the % of firms in Low income in 2011 to that in 2013?
Provide a succinct answer. 1.77. What is the ratio of the % of firms of Middle East & North Africa (all income levels) in 2011 to that in 2013?
Your answer should be compact. 0.17. What is the difference between the highest and the second highest % of firms of Fragile and conflict affected situations?
Offer a very short reply. 9.04. What is the difference between the highest and the second highest % of firms of Heavily indebted poor countries?
Give a very brief answer. 1.42. What is the difference between the highest and the second highest % of firms of Low income?
Give a very brief answer. 0.22. What is the difference between the highest and the second highest % of firms of Middle East & North Africa (all income levels)?
Offer a very short reply. 7.01. What is the difference between the highest and the lowest % of firms in Fragile and conflict affected situations?
Your answer should be very brief. 24.17. What is the difference between the highest and the lowest % of firms in Heavily indebted poor countries?
Offer a very short reply. 26.52. What is the difference between the highest and the lowest % of firms of Low income?
Offer a terse response. 21.62. What is the difference between the highest and the lowest % of firms in Middle East & North Africa (all income levels)?
Offer a terse response. 29.05. 